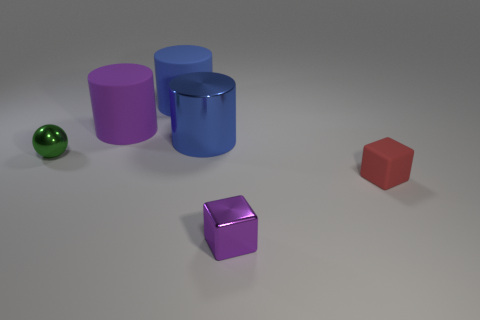Subtract all yellow cubes. How many blue cylinders are left? 2 Subtract all blue cylinders. How many cylinders are left? 1 Add 3 large metal things. How many objects exist? 9 Subtract all cubes. How many objects are left? 4 Subtract all tiny green metal spheres. Subtract all tiny purple things. How many objects are left? 4 Add 6 large purple objects. How many large purple objects are left? 7 Add 2 large purple cylinders. How many large purple cylinders exist? 3 Subtract 1 purple cubes. How many objects are left? 5 